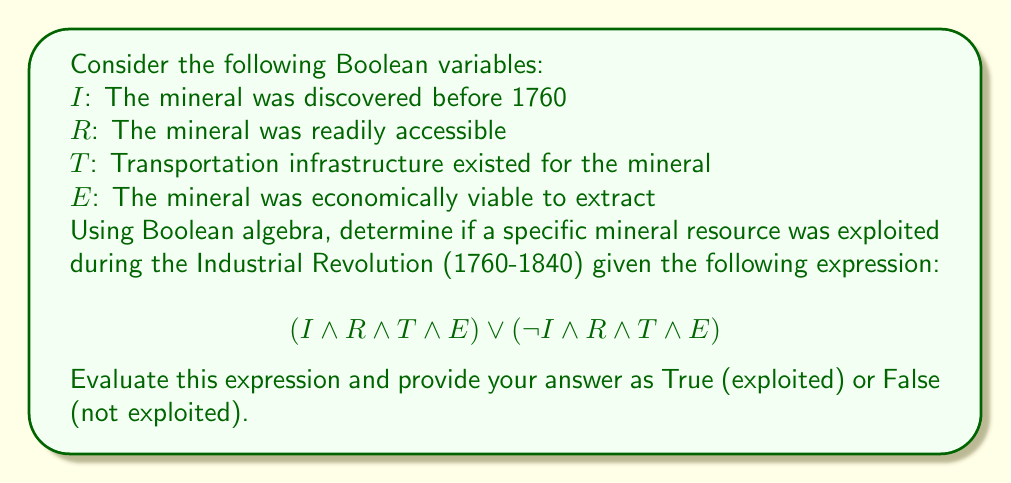Can you solve this math problem? Let's break this down step-by-step:

1) The expression consists of two main parts connected by an OR (∨) operation:
   $$(I \land R \land T \land E) \lor (\neg I \land R \land T \land E)$$

2) Let's evaluate each part separately:

   Part 1: $(I \land R \land T \land E)$
   This represents a mineral that was discovered before 1760 (I), readily accessible (R), had transportation infrastructure (T), and was economically viable (E).

   Part 2: $(\neg I \land R \land T \land E)$
   This represents a mineral that was NOT discovered before 1760 (¬I), but was readily accessible (R), had transportation infrastructure (T), and was economically viable (E).

3) The OR operation between these parts means that if either part is true, the whole expression is true.

4) Analyzing the expression:
   - Both parts require R, T, and E to be true.
   - The only difference is whether I is true (Part 1) or false (Part 2).

5) This logical structure covers all cases where a mineral could be exploited during the Industrial Revolution:
   - Those discovered before 1760 and meeting the other criteria
   - Those discovered after 1760 (but before 1840) and meeting the other criteria

6) Therefore, this expression will evaluate to True for any mineral that was exploited during the Industrial Revolution, regardless of when it was discovered, as long as it was readily accessible, had transportation infrastructure, and was economically viable to extract.
Answer: True 